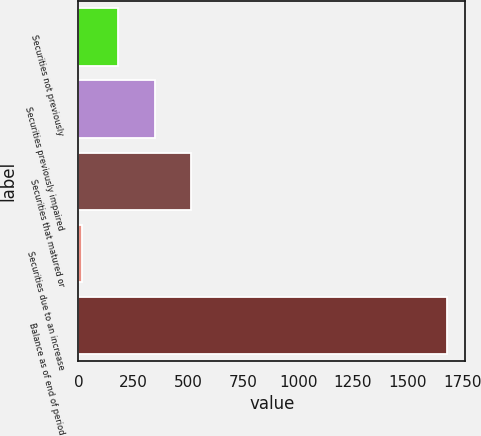Convert chart to OTSL. <chart><loc_0><loc_0><loc_500><loc_500><bar_chart><fcel>Securities not previously<fcel>Securities previously impaired<fcel>Securities that matured or<fcel>Securities due to an increase<fcel>Balance as of end of period<nl><fcel>182<fcel>348<fcel>514<fcel>16<fcel>1676<nl></chart> 